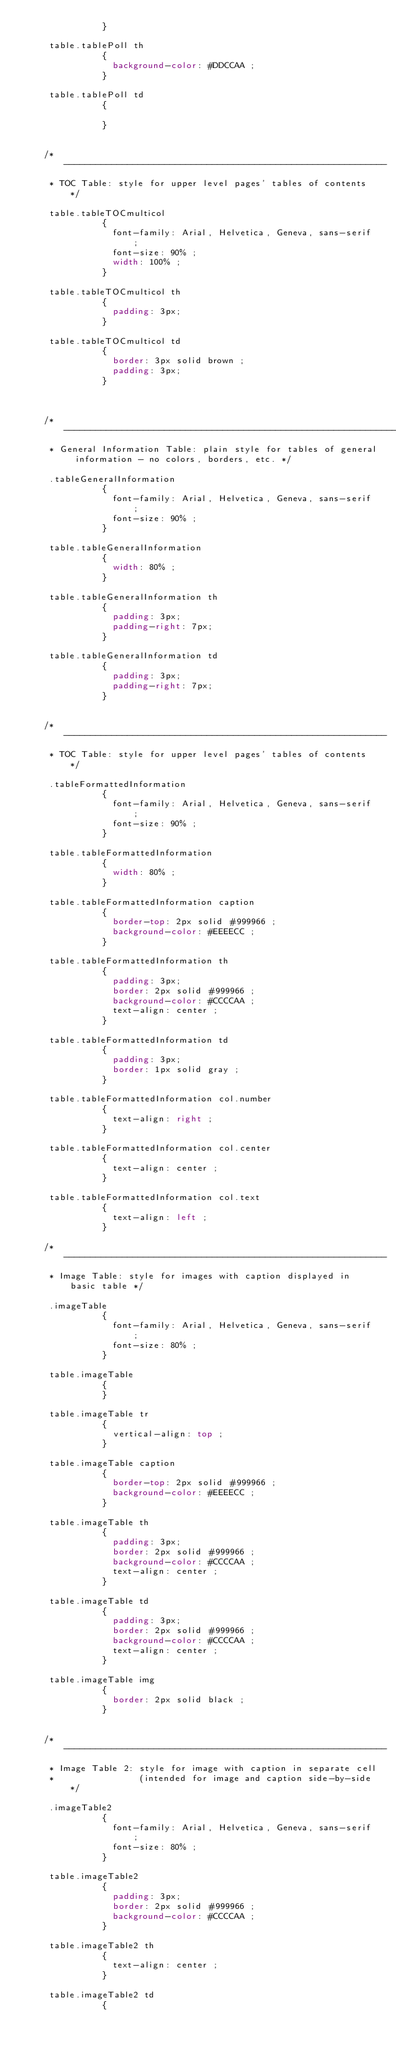<code> <loc_0><loc_0><loc_500><loc_500><_CSS_>               }

     table.tablePoll th
               {
                 background-color: #DDCCAA ;
               }

     table.tablePoll td
               {

               }


    /* -------------------------------------------------------------
     * TOC Table: style for upper level pages' tables of contents */

     table.tableTOCmulticol
               {
                 font-family: Arial, Helvetica, Geneva, sans-serif ;
                 font-size: 90% ;
                 width: 100% ;
               }

     table.tableTOCmulticol th
               {
                 padding: 3px;
               }

     table.tableTOCmulticol td
               {
                 border: 3px solid brown ;
                 padding: 3px;
               }



    /* ------------------------------------------------------------------------------------------------
     * General Information Table: plain style for tables of general information - no colors, borders, etc. */

     .tableGeneralInformation
               {
                 font-family: Arial, Helvetica, Geneva, sans-serif ;
                 font-size: 90% ;
               }

     table.tableGeneralInformation
               {
                 width: 80% ;
               }

     table.tableGeneralInformation th
               {
                 padding: 3px;
                 padding-right: 7px;
               }

     table.tableGeneralInformation td
               {
                 padding: 3px;
                 padding-right: 7px;
               }


    /* -------------------------------------------------------------
     * TOC Table: style for upper level pages' tables of contents */

     .tableFormattedInformation
               {
                 font-family: Arial, Helvetica, Geneva, sans-serif ;
                 font-size: 90% ;
               }

     table.tableFormattedInformation
               {
                 width: 80% ;
               }

     table.tableFormattedInformation caption
               {
                 border-top: 2px solid #999966 ;
                 background-color: #EEEECC ;
               }

     table.tableFormattedInformation th
               {
                 padding: 3px;
                 border: 2px solid #999966 ;
                 background-color: #CCCCAA ;
                 text-align: center ;
               }

     table.tableFormattedInformation td
               {
                 padding: 3px;
                 border: 1px solid gray ;
               }

     table.tableFormattedInformation col.number
               {
                 text-align: right ;
               }

     table.tableFormattedInformation col.center
               {
                 text-align: center ;
               }

     table.tableFormattedInformation col.text
               {
                 text-align: left ;
               }

    /* -------------------------------------------------------------
     * Image Table: style for images with caption displayed in basic table */

     .imageTable
               {
                 font-family: Arial, Helvetica, Geneva, sans-serif ;
                 font-size: 80% ;
               }

     table.imageTable
               {
               }

     table.imageTable tr
               {
                 vertical-align: top ;
               }

     table.imageTable caption
               {
                 border-top: 2px solid #999966 ;
                 background-color: #EEEECC ;
               }

     table.imageTable th
               {
                 padding: 3px;
                 border: 2px solid #999966 ;
                 background-color: #CCCCAA ;
                 text-align: center ;
               }

     table.imageTable td
               {
                 padding: 3px;
                 border: 2px solid #999966 ;
                 background-color: #CCCCAA ;
                 text-align: center ;
               }

     table.imageTable img
               {
                 border: 2px solid black ;
               }


    /* -------------------------------------------------------------
     * Image Table 2: style for image with caption in separate cell
     *                (intended for image and caption side-by-side */

     .imageTable2
               {
                 font-family: Arial, Helvetica, Geneva, sans-serif ;
                 font-size: 80% ;
               }

     table.imageTable2
               {
                 padding: 3px;
                 border: 2px solid #999966 ;
                 background-color: #CCCCAA ;
               }

     table.imageTable2 th
               {
                 text-align: center ;
               }

     table.imageTable2 td
               {</code> 